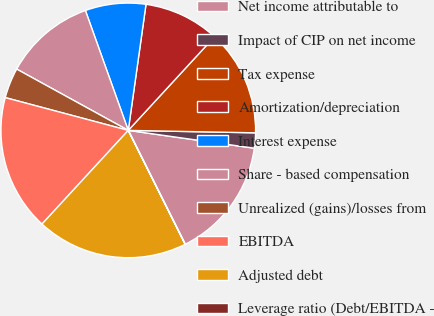<chart> <loc_0><loc_0><loc_500><loc_500><pie_chart><fcel>Net income attributable to<fcel>Impact of CIP on net income<fcel>Tax expense<fcel>Amortization/depreciation<fcel>Interest expense<fcel>Share - based compensation<fcel>Unrealized (gains)/losses from<fcel>EBITDA<fcel>Adjusted debt<fcel>Leverage ratio (Debt/EBITDA -<nl><fcel>15.38%<fcel>1.93%<fcel>13.46%<fcel>9.62%<fcel>7.69%<fcel>11.54%<fcel>3.85%<fcel>17.3%<fcel>19.22%<fcel>0.01%<nl></chart> 